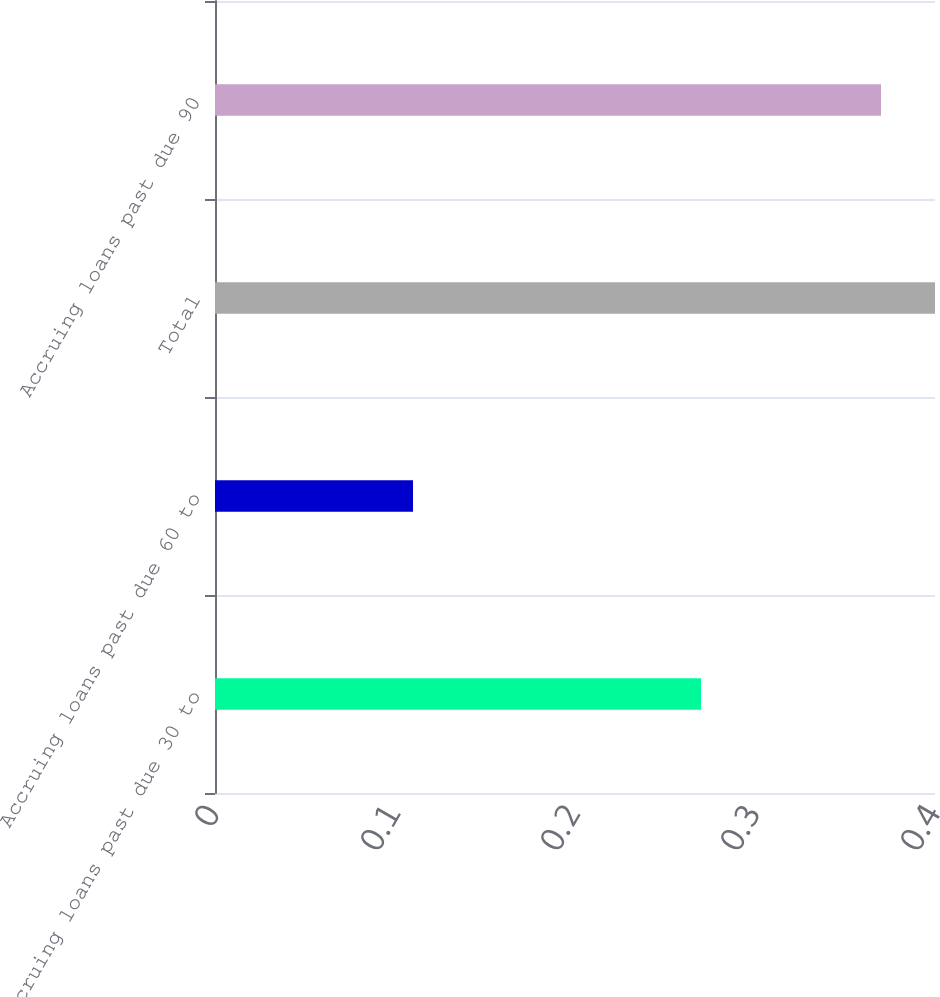<chart> <loc_0><loc_0><loc_500><loc_500><bar_chart><fcel>Accruing loans past due 30 to<fcel>Accruing loans past due 60 to<fcel>Total<fcel>Accruing loans past due 90<nl><fcel>0.27<fcel>0.11<fcel>0.4<fcel>0.37<nl></chart> 